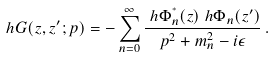<formula> <loc_0><loc_0><loc_500><loc_500>\ h { G } ( z , z ^ { \prime } ; p ) & = - \sum _ { n = 0 } ^ { \infty } \frac { \ h { \Phi } ^ { ^ { * } } _ { n } ( z ) \ h { \Phi } _ { n } ( z ^ { \prime } ) } { p ^ { 2 } + m ^ { 2 } _ { n } - i \epsilon } \, .</formula> 